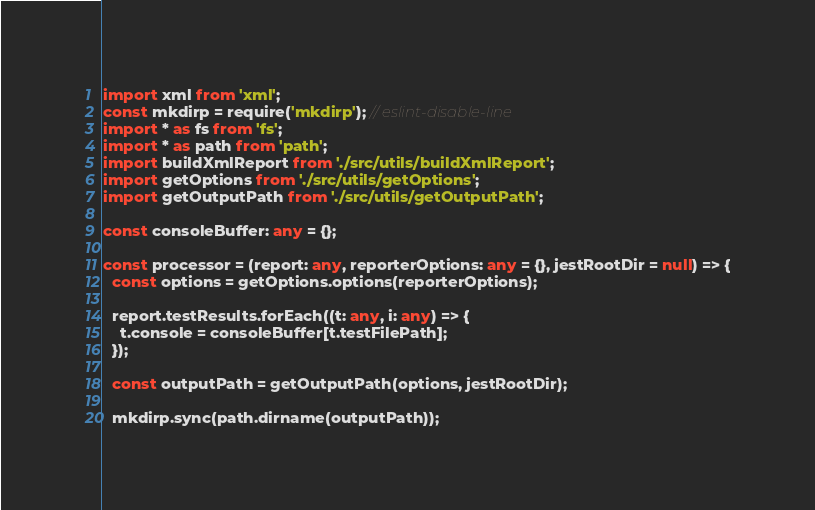Convert code to text. <code><loc_0><loc_0><loc_500><loc_500><_TypeScript_>import xml from 'xml';
const mkdirp = require('mkdirp'); // eslint-disable-line
import * as fs from 'fs';
import * as path from 'path';
import buildXmlReport from './src/utils/buildXmlReport';
import getOptions from './src/utils/getOptions';
import getOutputPath from './src/utils/getOutputPath';

const consoleBuffer: any = {};

const processor = (report: any, reporterOptions: any = {}, jestRootDir = null) => {
  const options = getOptions.options(reporterOptions);

  report.testResults.forEach((t: any, i: any) => {
    t.console = consoleBuffer[t.testFilePath];
  });

  const outputPath = getOutputPath(options, jestRootDir);

  mkdirp.sync(path.dirname(outputPath));
</code> 